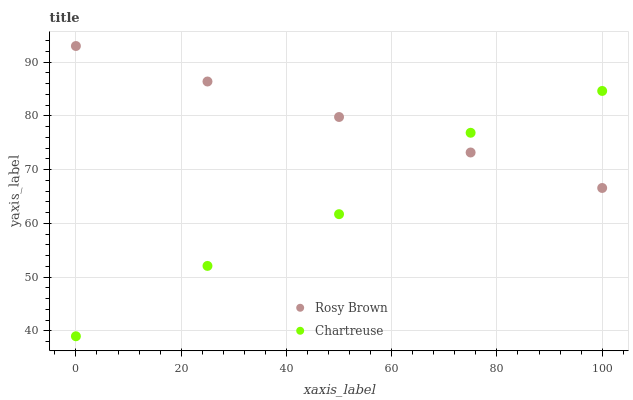Does Chartreuse have the minimum area under the curve?
Answer yes or no. Yes. Does Rosy Brown have the maximum area under the curve?
Answer yes or no. Yes. Does Rosy Brown have the minimum area under the curve?
Answer yes or no. No. Is Rosy Brown the smoothest?
Answer yes or no. Yes. Is Chartreuse the roughest?
Answer yes or no. Yes. Is Rosy Brown the roughest?
Answer yes or no. No. Does Chartreuse have the lowest value?
Answer yes or no. Yes. Does Rosy Brown have the lowest value?
Answer yes or no. No. Does Rosy Brown have the highest value?
Answer yes or no. Yes. Does Chartreuse intersect Rosy Brown?
Answer yes or no. Yes. Is Chartreuse less than Rosy Brown?
Answer yes or no. No. Is Chartreuse greater than Rosy Brown?
Answer yes or no. No. 